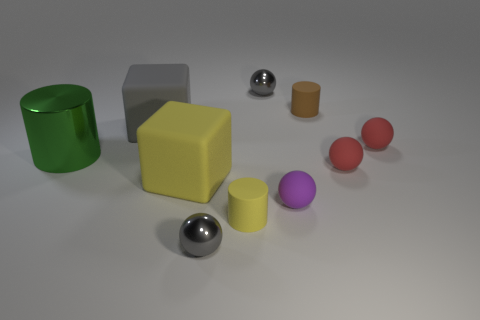Subtract 1 balls. How many balls are left? 4 Subtract all tiny purple matte spheres. How many spheres are left? 4 Subtract all yellow balls. Subtract all green cylinders. How many balls are left? 5 Subtract all blocks. How many objects are left? 8 Subtract all small objects. Subtract all large red rubber spheres. How many objects are left? 3 Add 8 large yellow cubes. How many large yellow cubes are left? 9 Add 2 gray metal things. How many gray metal things exist? 4 Subtract 1 yellow blocks. How many objects are left? 9 